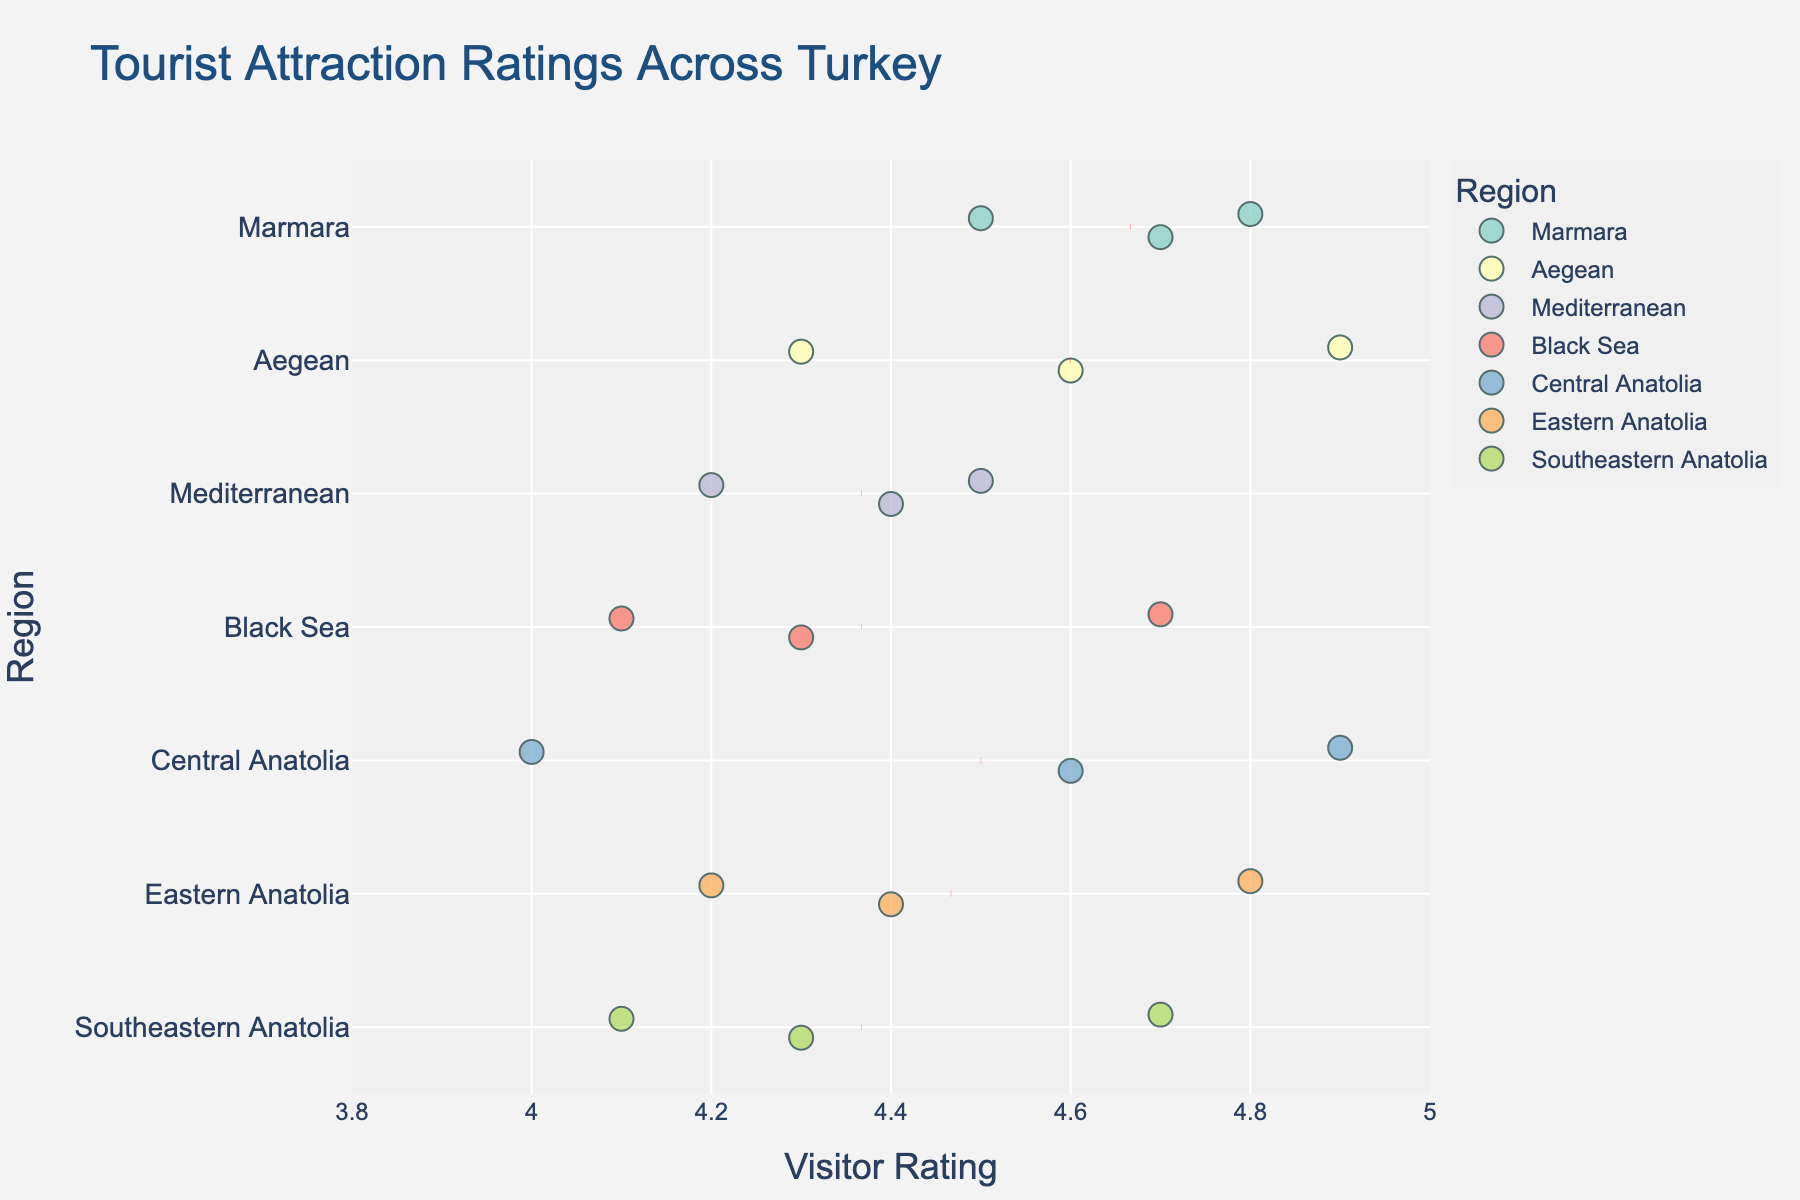What is the title of the plot? The title is usually found at the very top of the plot and is meant to provide an overview of what the plot represents, usually in larger and bold font.
Answer: Tourist Attraction Ratings Across Turkey Which tourist attraction in the Marmara region has the highest rating? Look at the data points in the Marmara region and note the attraction with the highest rating value on the x-axis.
Answer: Hagia Sophia How many tourist attractions in the plot have ratings of 4.9? Count the individual data points marked at the 4.9 rating value on the x-axis.
Answer: 2 What is the average rating for the attractions in the Aegean region? Compute the average by summing the ratings of all attractions in the Aegean region and dividing by the number of attractions. (Ephesus: 4.9, Pamukkale: 4.6, Bodrum Castle: 4.3) = (4.9 + 4.6 + 4.3) / 3
Answer: 4.6 Which region shows the widest spread of ratings? Compare the range (difference between the highest and the lowest ratings) of each region by observing the distance between the farthest data points.
Answer: Black Sea Which region has the highest average rating? Check the red dashed lines added for the average rating of each region and identify the highest one.
Answer: Marmara Are there any regions where all attractions have ratings less than 4.5? Observe each region's data points to see if any region has all points with ratings below 4.5.
Answer: Black Sea Is there any attraction in the Eastern Anatolia region with a rating lower than 4.2? Examine the data points in the Eastern Anatolia region and check if any are lower than the 4.2 rating mark.
Answer: No Which tourist attraction in the Southeastern Anatolia region has the lowest rating? Look for the data point in the Southeastern Anatolia region with the lowest rating value on the x-axis.
Answer: Gaziantep Zoo How do the average ratings of Marmara and Central Anatolia regions compare? Locate the red dashed lines for average ratings for Marmara and Central Anatolia regions and compare their positions on the x-axis.
Answer: Marmara's average is higher than Central Anatolia's 